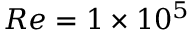Convert formula to latex. <formula><loc_0><loc_0><loc_500><loc_500>R e = 1 \times 1 0 ^ { 5 }</formula> 